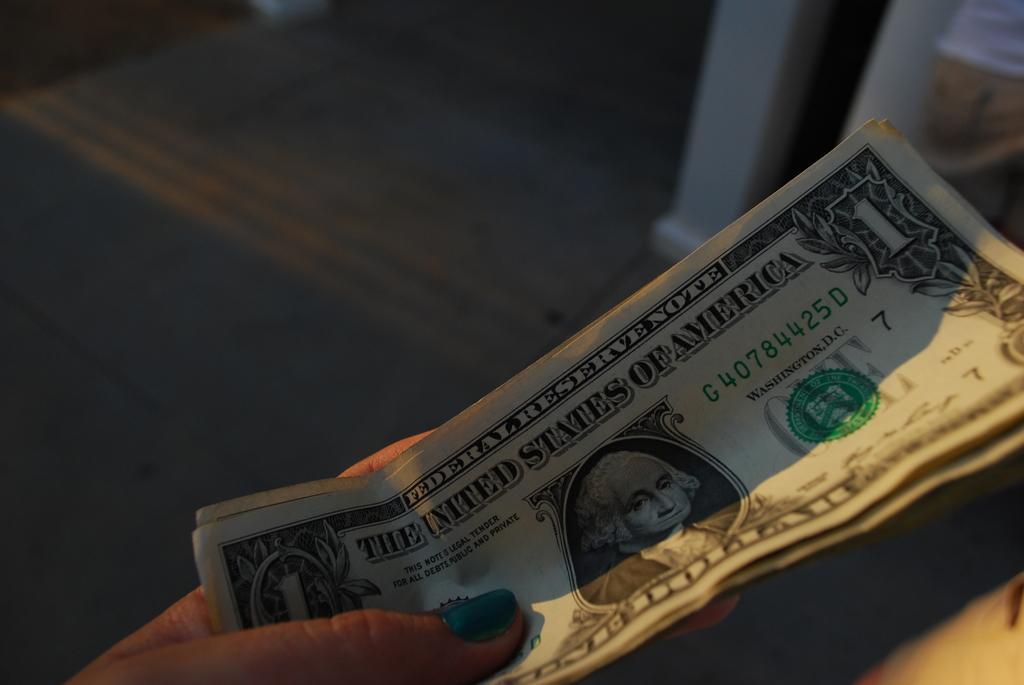Please provide a concise description of this image. Here in this picture we can see dollar bills present in a person's hand. 